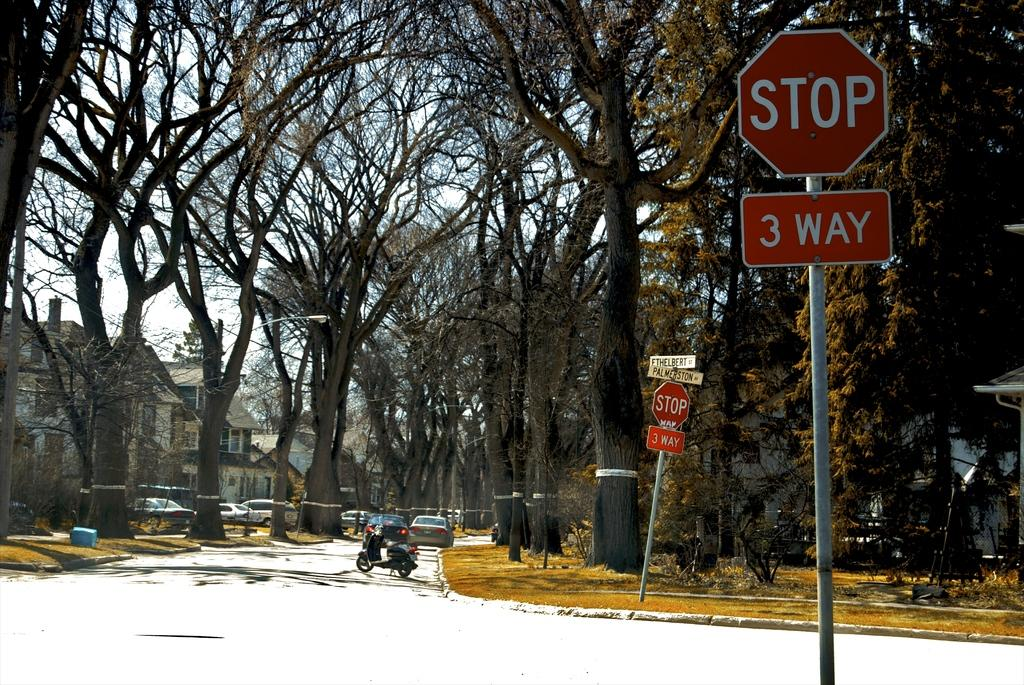<image>
Give a short and clear explanation of the subsequent image. A 3 way stop at the corner of Palmerston Av and another street. 